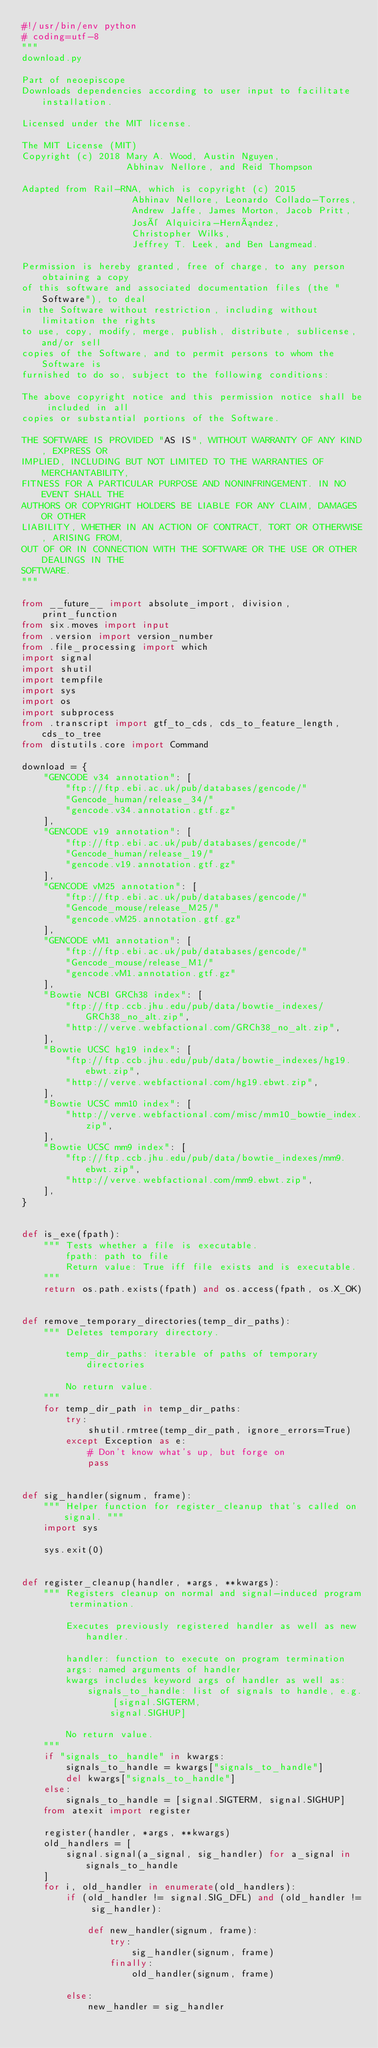<code> <loc_0><loc_0><loc_500><loc_500><_Python_>#!/usr/bin/env python
# coding=utf-8
"""
download.py

Part of neoepiscope
Downloads dependencies according to user input to facilitate installation.

Licensed under the MIT license.

The MIT License (MIT)
Copyright (c) 2018 Mary A. Wood, Austin Nguyen,
                   Abhinav Nellore, and Reid Thompson

Adapted from Rail-RNA, which is copyright (c) 2015 
                    Abhinav Nellore, Leonardo Collado-Torres,
                    Andrew Jaffe, James Morton, Jacob Pritt,
                    José Alquicira-Hernández,
                    Christopher Wilks,
                    Jeffrey T. Leek, and Ben Langmead.

Permission is hereby granted, free of charge, to any person obtaining a copy
of this software and associated documentation files (the "Software"), to deal
in the Software without restriction, including without limitation the rights
to use, copy, modify, merge, publish, distribute, sublicense, and/or sell
copies of the Software, and to permit persons to whom the Software is
furnished to do so, subject to the following conditions:

The above copyright notice and this permission notice shall be included in all
copies or substantial portions of the Software.

THE SOFTWARE IS PROVIDED "AS IS", WITHOUT WARRANTY OF ANY KIND, EXPRESS OR
IMPLIED, INCLUDING BUT NOT LIMITED TO THE WARRANTIES OF MERCHANTABILITY,
FITNESS FOR A PARTICULAR PURPOSE AND NONINFRINGEMENT. IN NO EVENT SHALL THE
AUTHORS OR COPYRIGHT HOLDERS BE LIABLE FOR ANY CLAIM, DAMAGES OR OTHER
LIABILITY, WHETHER IN AN ACTION OF CONTRACT, TORT OR OTHERWISE, ARISING FROM,
OUT OF OR IN CONNECTION WITH THE SOFTWARE OR THE USE OR OTHER DEALINGS IN THE
SOFTWARE.
"""

from __future__ import absolute_import, division, print_function
from six.moves import input
from .version import version_number
from .file_processing import which
import signal
import shutil
import tempfile
import sys
import os
import subprocess
from .transcript import gtf_to_cds, cds_to_feature_length, cds_to_tree
from distutils.core import Command

download = {
    "GENCODE v34 annotation": [
        "ftp://ftp.ebi.ac.uk/pub/databases/gencode/"
        "Gencode_human/release_34/"
        "gencode.v34.annotation.gtf.gz"
    ],
    "GENCODE v19 annotation": [
        "ftp://ftp.ebi.ac.uk/pub/databases/gencode/"
        "Gencode_human/release_19/"
        "gencode.v19.annotation.gtf.gz"
    ],
    "GENCODE vM25 annotation": [
        "ftp://ftp.ebi.ac.uk/pub/databases/gencode/"
        "Gencode_mouse/release_M25/"
        "gencode.vM25.annotation.gtf.gz"
    ],
    "GENCODE vM1 annotation": [
        "ftp://ftp.ebi.ac.uk/pub/databases/gencode/"
        "Gencode_mouse/release_M1/"
        "gencode.vM1.annotation.gtf.gz"
    ],
    "Bowtie NCBI GRCh38 index": [
        "ftp://ftp.ccb.jhu.edu/pub/data/bowtie_indexes/GRCh38_no_alt.zip",
        "http://verve.webfactional.com/GRCh38_no_alt.zip",
    ],
    "Bowtie UCSC hg19 index": [
        "ftp://ftp.ccb.jhu.edu/pub/data/bowtie_indexes/hg19.ebwt.zip",
        "http://verve.webfactional.com/hg19.ebwt.zip",
    ],
    "Bowtie UCSC mm10 index": [
        "http://verve.webfactional.com/misc/mm10_bowtie_index.zip",
    ],
    "Bowtie UCSC mm9 index": [
        "ftp://ftp.ccb.jhu.edu/pub/data/bowtie_indexes/mm9.ebwt.zip",
        "http://verve.webfactional.com/mm9.ebwt.zip",
    ],
}


def is_exe(fpath):
    """ Tests whether a file is executable.
        fpath: path to file
        Return value: True iff file exists and is executable.
    """
    return os.path.exists(fpath) and os.access(fpath, os.X_OK)


def remove_temporary_directories(temp_dir_paths):
    """ Deletes temporary directory.

        temp_dir_paths: iterable of paths of temporary directories

        No return value.
    """
    for temp_dir_path in temp_dir_paths:
        try:
            shutil.rmtree(temp_dir_path, ignore_errors=True)
        except Exception as e:
            # Don't know what's up, but forge on
            pass


def sig_handler(signum, frame):
    """ Helper function for register_cleanup that's called on signal. """
    import sys

    sys.exit(0)


def register_cleanup(handler, *args, **kwargs):
    """ Registers cleanup on normal and signal-induced program termination.

        Executes previously registered handler as well as new handler.

        handler: function to execute on program termination
        args: named arguments of handler
        kwargs includes keyword args of handler as well as:
            signals_to_handle: list of signals to handle, e.g. [signal.SIGTERM,
                signal.SIGHUP]

        No return value.
    """
    if "signals_to_handle" in kwargs:
        signals_to_handle = kwargs["signals_to_handle"]
        del kwargs["signals_to_handle"]
    else:
        signals_to_handle = [signal.SIGTERM, signal.SIGHUP]
    from atexit import register

    register(handler, *args, **kwargs)
    old_handlers = [
        signal.signal(a_signal, sig_handler) for a_signal in signals_to_handle
    ]
    for i, old_handler in enumerate(old_handlers):
        if (old_handler != signal.SIG_DFL) and (old_handler != sig_handler):

            def new_handler(signum, frame):
                try:
                    sig_handler(signum, frame)
                finally:
                    old_handler(signum, frame)

        else:
            new_handler = sig_handler</code> 